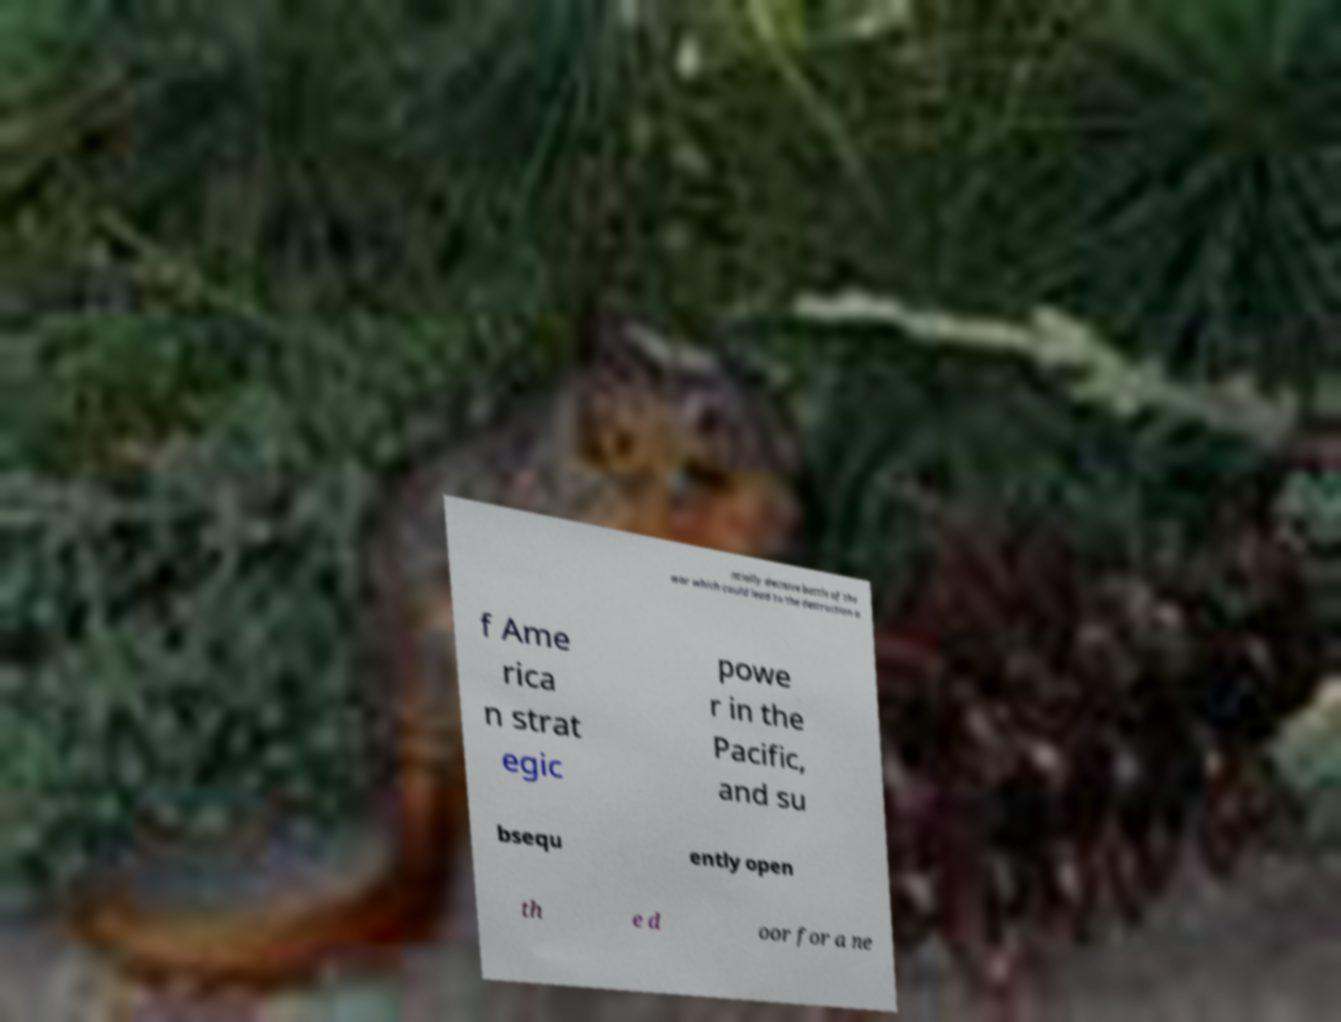Please identify and transcribe the text found in this image. ntially decisive battle of the war which could lead to the destruction o f Ame rica n strat egic powe r in the Pacific, and su bsequ ently open th e d oor for a ne 